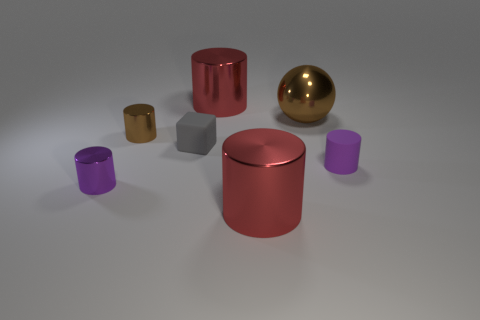What number of other things are the same size as the brown metallic sphere?
Your response must be concise. 2. There is a purple object that is right of the brown cylinder; does it have the same shape as the small purple thing left of the tiny brown thing?
Ensure brevity in your answer.  Yes. What number of objects are shiny cubes or metal objects that are right of the matte block?
Your answer should be very brief. 3. The cylinder that is behind the tiny purple metallic cylinder and in front of the cube is made of what material?
Give a very brief answer. Rubber. Is there any other thing that is the same shape as the tiny gray rubber object?
Offer a terse response. No. What color is the thing that is made of the same material as the tiny block?
Provide a succinct answer. Purple. What number of objects are either tiny purple shiny objects or tiny cylinders?
Your answer should be compact. 3. Is the size of the brown ball the same as the matte object behind the matte cylinder?
Provide a short and direct response. No. There is a big shiny object that is behind the brown object right of the metal cylinder that is behind the big metal ball; what is its color?
Provide a short and direct response. Red. The sphere is what color?
Provide a succinct answer. Brown. 